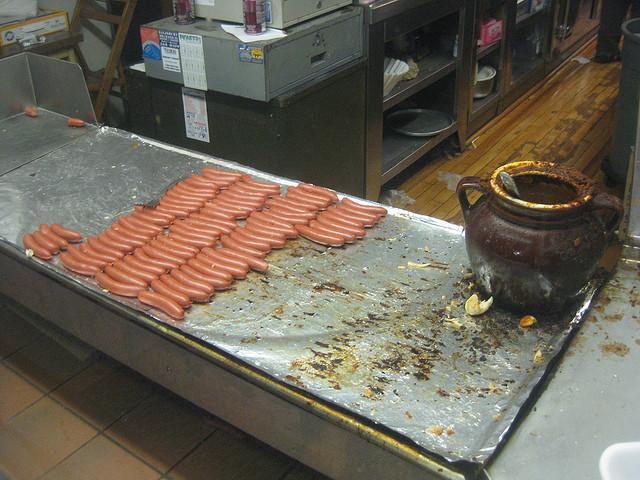How many columns of hot dogs are lined up on the grill?
Give a very brief answer. 5. 